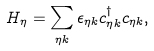<formula> <loc_0><loc_0><loc_500><loc_500>H _ { \eta } = \sum _ { \eta k } \epsilon _ { \eta k } c _ { \eta k } ^ { \dagger } c _ { \eta k } ,</formula> 